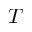Convert formula to latex. <formula><loc_0><loc_0><loc_500><loc_500>T</formula> 